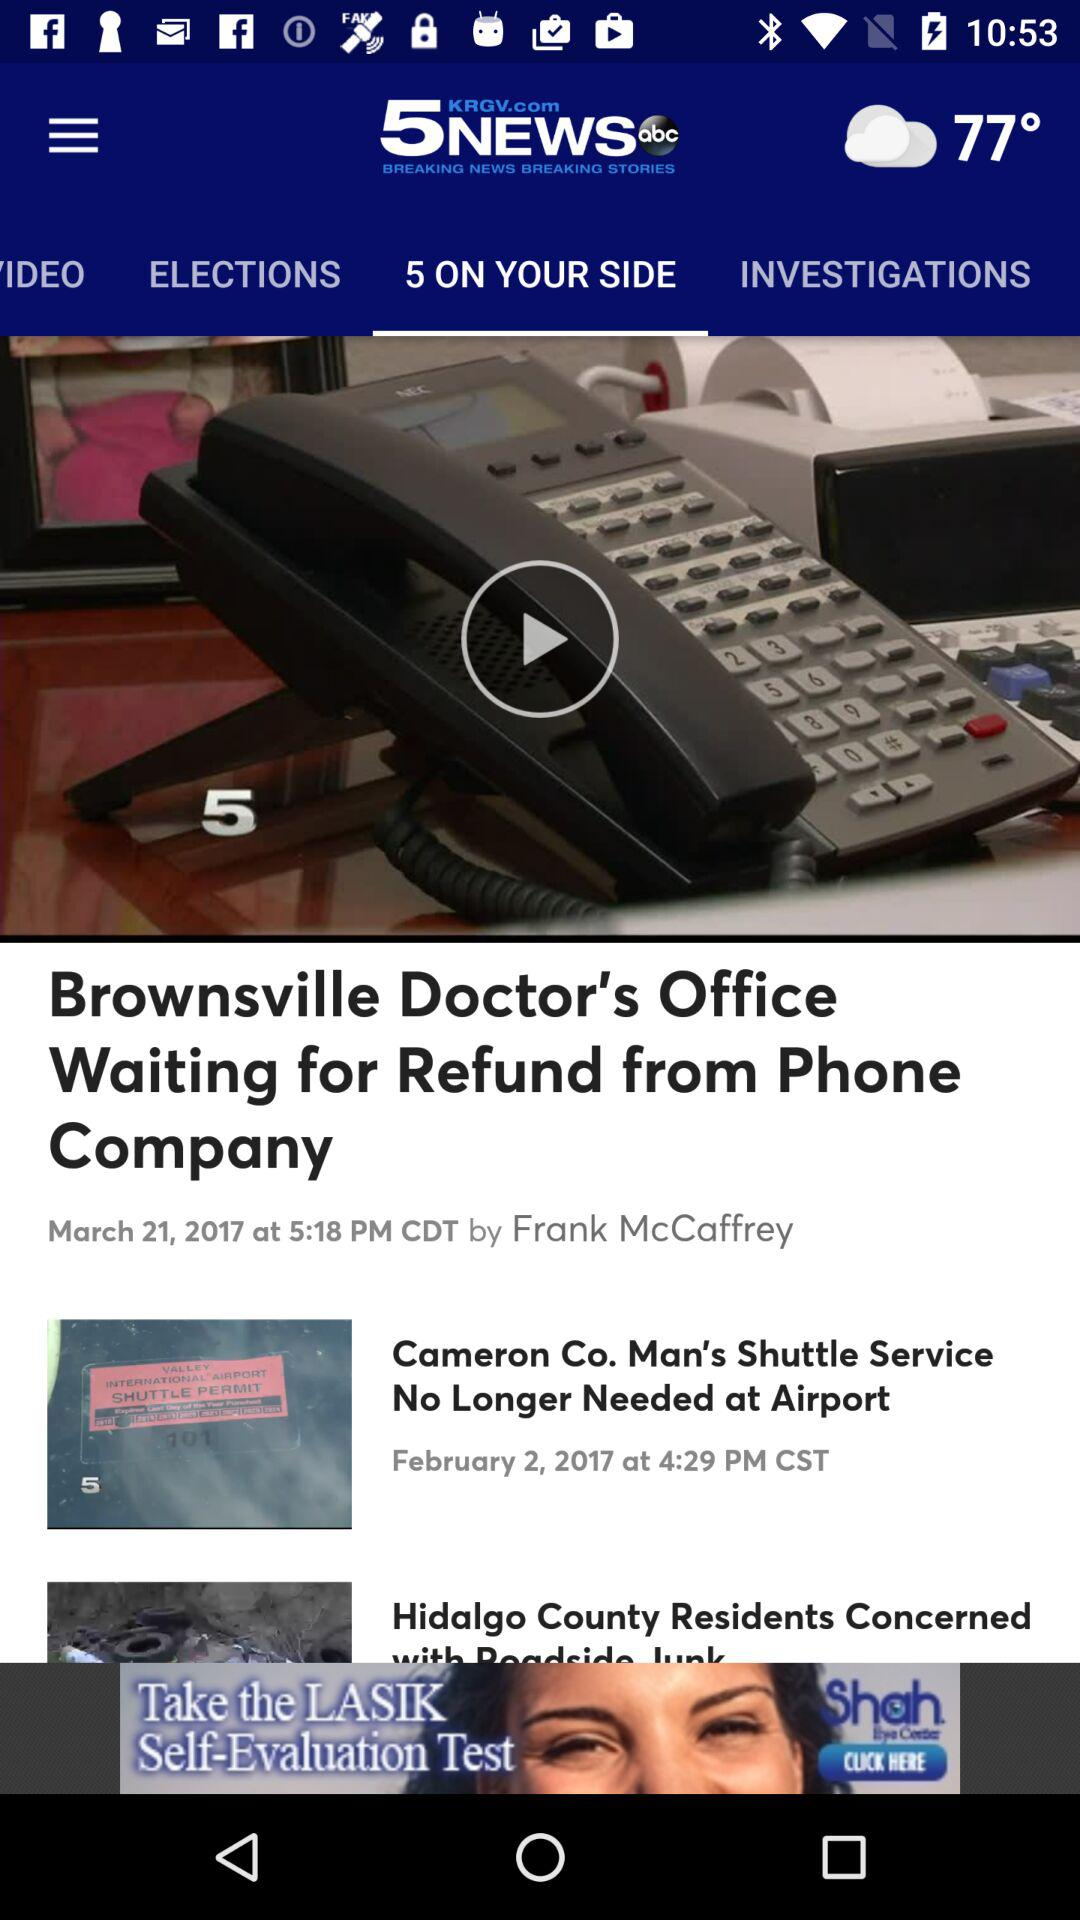When was the news "Brownsville Doctor's Office Waiting for Refund from Phone Company" uploaded? The news was uploaded on March 21, 2017 at 5:18 PM CDT. 